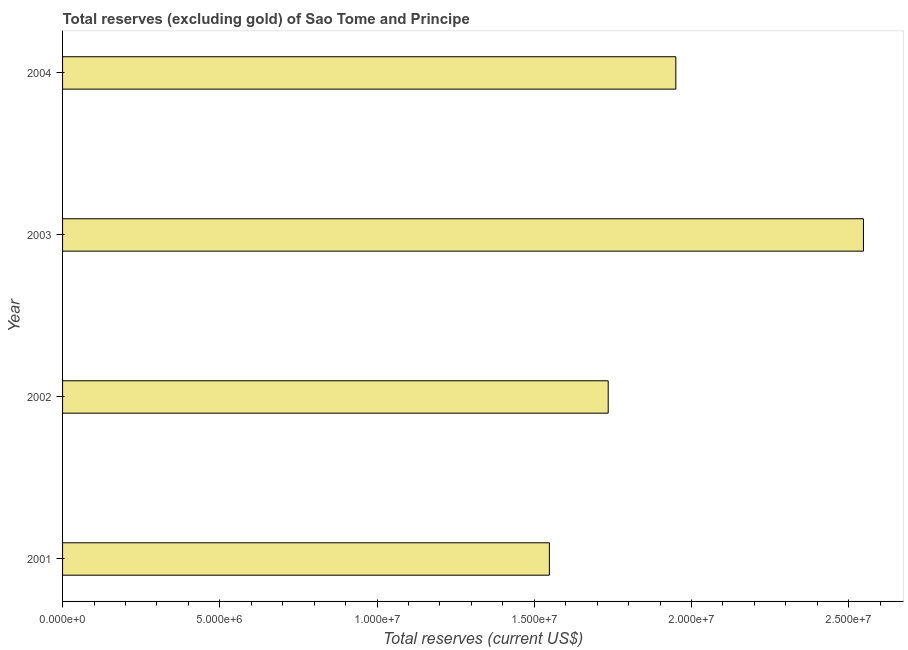Does the graph contain any zero values?
Give a very brief answer. No. What is the title of the graph?
Offer a very short reply. Total reserves (excluding gold) of Sao Tome and Principe. What is the label or title of the X-axis?
Ensure brevity in your answer.  Total reserves (current US$). What is the total reserves (excluding gold) in 2004?
Offer a terse response. 1.95e+07. Across all years, what is the maximum total reserves (excluding gold)?
Your answer should be very brief. 2.55e+07. Across all years, what is the minimum total reserves (excluding gold)?
Your response must be concise. 1.55e+07. In which year was the total reserves (excluding gold) maximum?
Your answer should be compact. 2003. What is the sum of the total reserves (excluding gold)?
Your answer should be very brief. 7.78e+07. What is the difference between the total reserves (excluding gold) in 2001 and 2002?
Offer a very short reply. -1.87e+06. What is the average total reserves (excluding gold) per year?
Offer a very short reply. 1.95e+07. What is the median total reserves (excluding gold)?
Your response must be concise. 1.84e+07. In how many years, is the total reserves (excluding gold) greater than 13000000 US$?
Offer a very short reply. 4. What is the ratio of the total reserves (excluding gold) in 2003 to that in 2004?
Offer a terse response. 1.31. Is the total reserves (excluding gold) in 2002 less than that in 2004?
Offer a very short reply. Yes. What is the difference between the highest and the second highest total reserves (excluding gold)?
Your answer should be compact. 5.97e+06. Is the sum of the total reserves (excluding gold) in 2001 and 2004 greater than the maximum total reserves (excluding gold) across all years?
Offer a very short reply. Yes. What is the difference between the highest and the lowest total reserves (excluding gold)?
Provide a succinct answer. 9.99e+06. How many bars are there?
Offer a very short reply. 4. Are all the bars in the graph horizontal?
Your response must be concise. Yes. What is the difference between two consecutive major ticks on the X-axis?
Make the answer very short. 5.00e+06. Are the values on the major ticks of X-axis written in scientific E-notation?
Ensure brevity in your answer.  Yes. What is the Total reserves (current US$) in 2001?
Give a very brief answer. 1.55e+07. What is the Total reserves (current US$) in 2002?
Provide a short and direct response. 1.74e+07. What is the Total reserves (current US$) in 2003?
Provide a short and direct response. 2.55e+07. What is the Total reserves (current US$) of 2004?
Offer a very short reply. 1.95e+07. What is the difference between the Total reserves (current US$) in 2001 and 2002?
Your answer should be very brief. -1.87e+06. What is the difference between the Total reserves (current US$) in 2001 and 2003?
Provide a succinct answer. -9.99e+06. What is the difference between the Total reserves (current US$) in 2001 and 2004?
Keep it short and to the point. -4.02e+06. What is the difference between the Total reserves (current US$) in 2002 and 2003?
Keep it short and to the point. -8.12e+06. What is the difference between the Total reserves (current US$) in 2002 and 2004?
Offer a terse response. -2.15e+06. What is the difference between the Total reserves (current US$) in 2003 and 2004?
Your answer should be very brief. 5.97e+06. What is the ratio of the Total reserves (current US$) in 2001 to that in 2002?
Make the answer very short. 0.89. What is the ratio of the Total reserves (current US$) in 2001 to that in 2003?
Provide a succinct answer. 0.61. What is the ratio of the Total reserves (current US$) in 2001 to that in 2004?
Keep it short and to the point. 0.79. What is the ratio of the Total reserves (current US$) in 2002 to that in 2003?
Give a very brief answer. 0.68. What is the ratio of the Total reserves (current US$) in 2002 to that in 2004?
Make the answer very short. 0.89. What is the ratio of the Total reserves (current US$) in 2003 to that in 2004?
Offer a terse response. 1.31. 